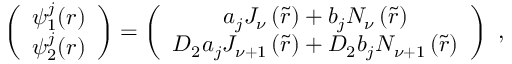Convert formula to latex. <formula><loc_0><loc_0><loc_500><loc_500>\left ( \begin{array} { c } { { \psi _ { 1 } ^ { j } ( r ) } } \\ { { \psi _ { 2 } ^ { j } ( r ) } } \end{array} \right ) = \left ( \begin{array} { c } { { a _ { j } J _ { \nu } \left ( \tilde { r } \right ) + b _ { j } N _ { \nu } \left ( \tilde { r } \right ) } } \\ { { D _ { 2 } a _ { j } J _ { \nu + 1 } \left ( \tilde { r } \right ) + D _ { 2 } b _ { j } N _ { \nu + 1 } \left ( \tilde { r } \right ) } } \end{array} \right ) \ ,</formula> 